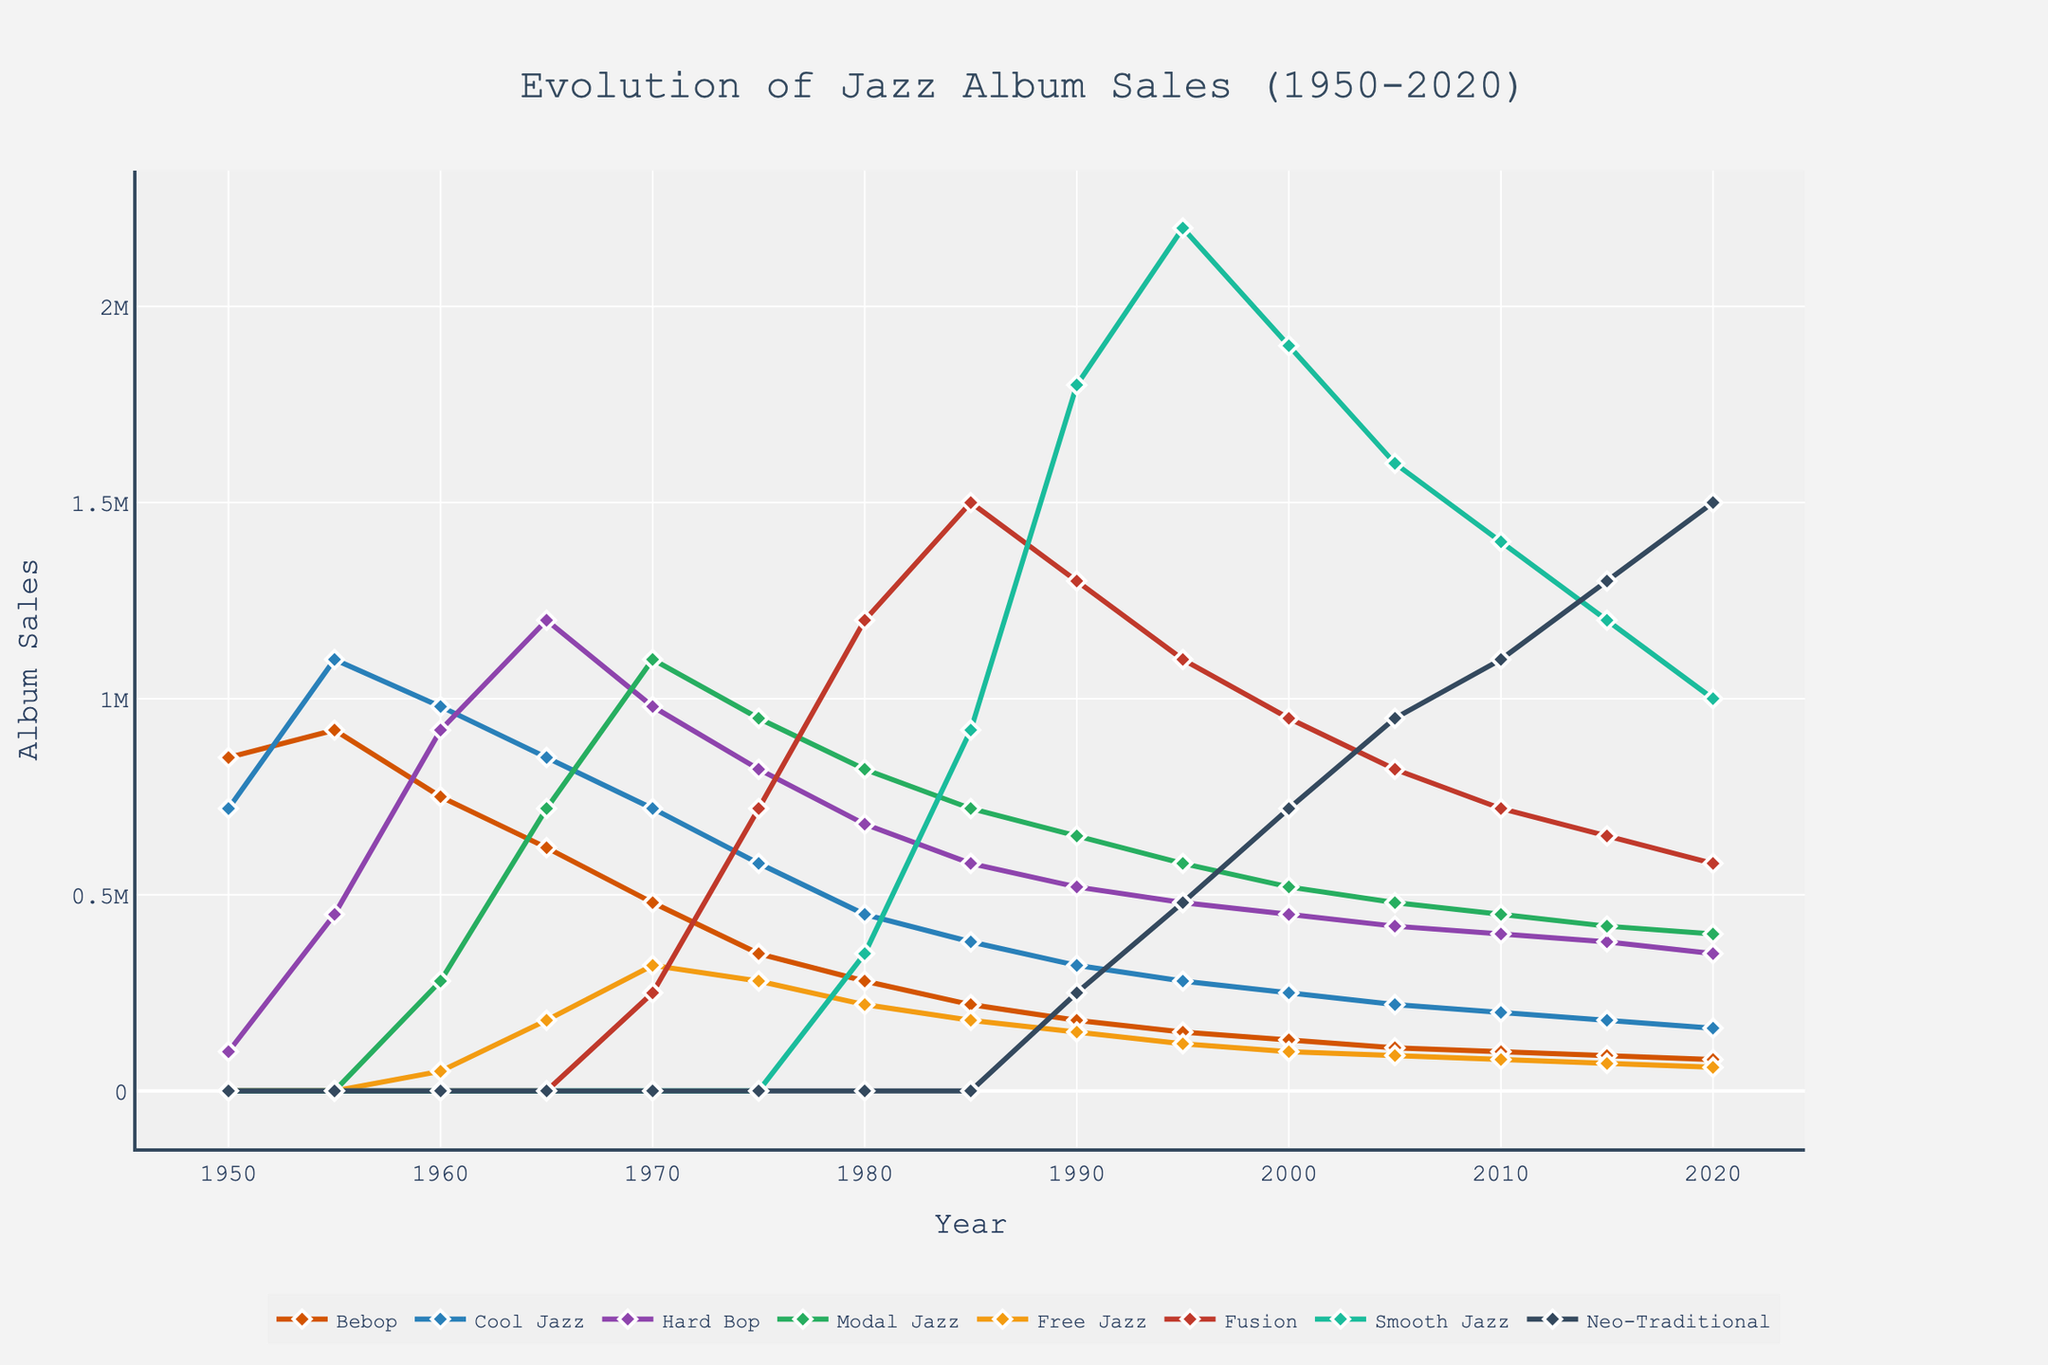What year had the highest album sales for Fusion? We can observe the highest peak in the Fusion sales curve, which occurs around 1985.
Answer: 1985 Which subgenre had the highest album sales in 2020? Look at the end of the lines on the right side of the chart for the year 2020 and compare their heights. The Neo-Traditional line is the highest.
Answer: Neo-Traditional How did Bebop album sales change from 1950 to 2020? Check the starting point in 1950 and the end point in 2020 for the Bebop line. Note the sales values in these years to observe the trend from 850,000 in 1950 to 80,000 in 2020.
Answer: Decreased Which subgenres showed a steady increase in album sales over time? Trace each line from left to right, identifying lines that consistently rise. Neo-Traditional and Smooth Jazz both show a steady increase in sales.
Answer: Neo-Traditional, Smooth Jazz When did Free Jazz album sales peak and what was the value? Follow the Free Jazz line to its highest point, which occurs around 1970 with sales approximately at 320,000.
Answer: 1970, 320,000 What were the approximate album sales for Hard Bop in 1965 compared to Modal Jazz in the same year? Check the intersection of the Hard Bop and Modal Jazz lines for the year 1965. Hard Bop had sales around 1,200,000 whereas Modal Jazz had sales around 720,000.
Answer: Hard Bop: 1,200,000, Modal Jazz: 720,000 Which subgenre experienced the most significant decline in album sales from its peak to 2020? Identify the highest peak of each subgenre and trace its decline to 2020. Bebop peaks around 1955 with 920,000 and declines to 80,000 by 2020, which is the most significant decline.
Answer: Bebop Compare the album sales trend of Cool Jazz and Fusion between 1975 and 1990. Trace the lines for Cool Jazz and Fusion between these years. Cool Jazz shows a declining trend, while Fusion increases significantly, peaking around 1985.
Answer: Cool Jazz declined, Fusion increased What year did Smooth Jazz surpass Fusion in album sales? Compare the intersection of the Smooth Jazz and Fusion lines. This occurs around 1990.
Answer: 1990 